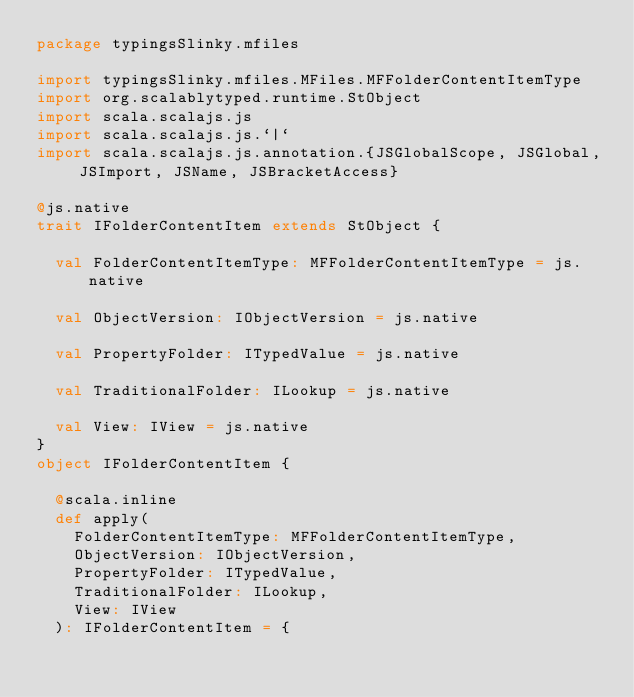<code> <loc_0><loc_0><loc_500><loc_500><_Scala_>package typingsSlinky.mfiles

import typingsSlinky.mfiles.MFiles.MFFolderContentItemType
import org.scalablytyped.runtime.StObject
import scala.scalajs.js
import scala.scalajs.js.`|`
import scala.scalajs.js.annotation.{JSGlobalScope, JSGlobal, JSImport, JSName, JSBracketAccess}

@js.native
trait IFolderContentItem extends StObject {
  
  val FolderContentItemType: MFFolderContentItemType = js.native
  
  val ObjectVersion: IObjectVersion = js.native
  
  val PropertyFolder: ITypedValue = js.native
  
  val TraditionalFolder: ILookup = js.native
  
  val View: IView = js.native
}
object IFolderContentItem {
  
  @scala.inline
  def apply(
    FolderContentItemType: MFFolderContentItemType,
    ObjectVersion: IObjectVersion,
    PropertyFolder: ITypedValue,
    TraditionalFolder: ILookup,
    View: IView
  ): IFolderContentItem = {</code> 